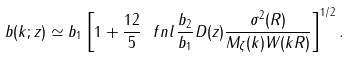Convert formula to latex. <formula><loc_0><loc_0><loc_500><loc_500>b ( k ; z ) \simeq b _ { 1 } \left [ 1 + \frac { 1 2 } { 5 } \ f n l \, \frac { b _ { 2 } } { b _ { 1 } } D ( z ) \frac { \sigma ^ { 2 } ( R ) } { M _ { \zeta } ( k ) W ( k R ) } \right ] ^ { 1 / 2 } .</formula> 